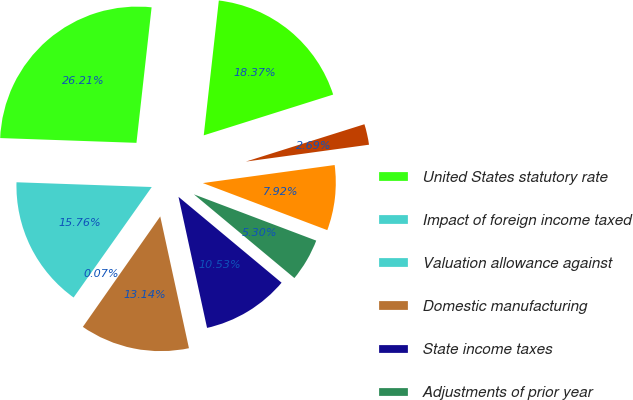Convert chart to OTSL. <chart><loc_0><loc_0><loc_500><loc_500><pie_chart><fcel>United States statutory rate<fcel>Impact of foreign income taxed<fcel>Valuation allowance against<fcel>Domestic manufacturing<fcel>State income taxes<fcel>Adjustments of prior year<fcel>Other impact of foreign<fcel>Other items net<fcel>Total effective tax rate on<nl><fcel>26.21%<fcel>15.76%<fcel>0.07%<fcel>13.14%<fcel>10.53%<fcel>5.3%<fcel>7.92%<fcel>2.69%<fcel>18.37%<nl></chart> 